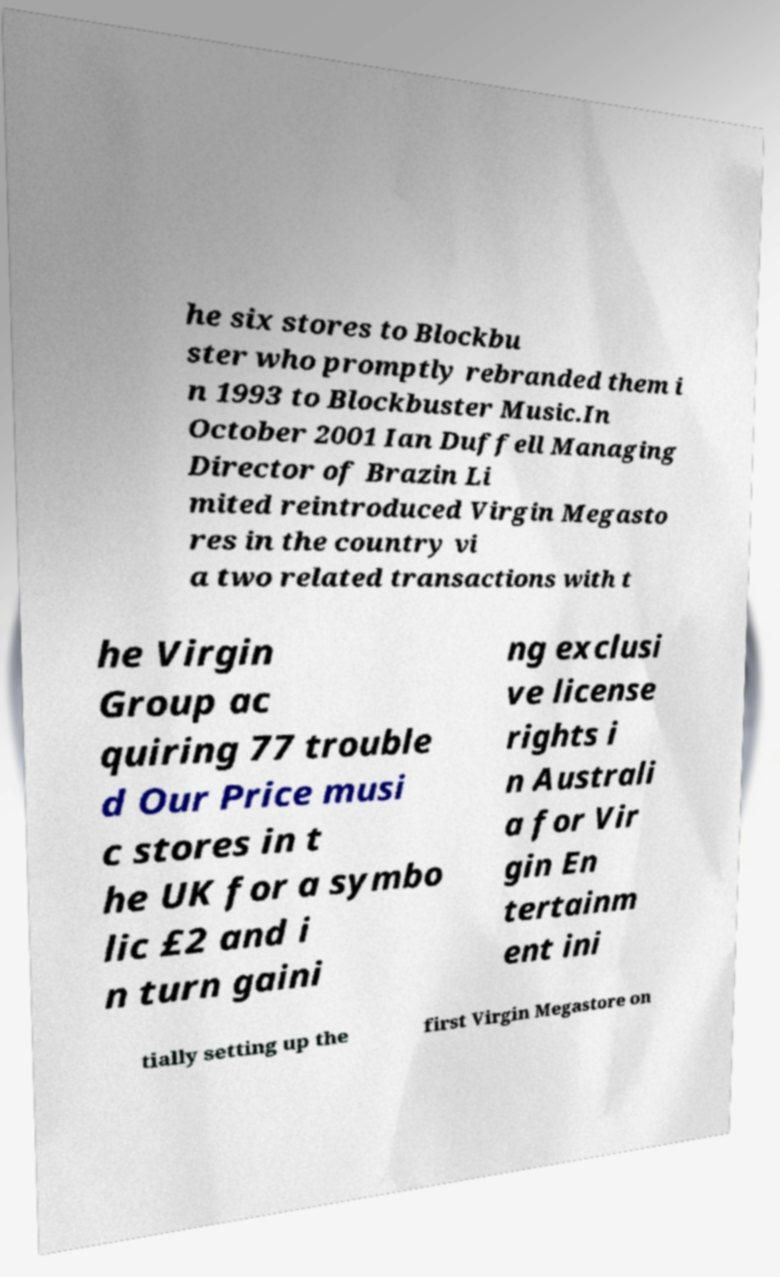Could you assist in decoding the text presented in this image and type it out clearly? he six stores to Blockbu ster who promptly rebranded them i n 1993 to Blockbuster Music.In October 2001 Ian Duffell Managing Director of Brazin Li mited reintroduced Virgin Megasto res in the country vi a two related transactions with t he Virgin Group ac quiring 77 trouble d Our Price musi c stores in t he UK for a symbo lic £2 and i n turn gaini ng exclusi ve license rights i n Australi a for Vir gin En tertainm ent ini tially setting up the first Virgin Megastore on 